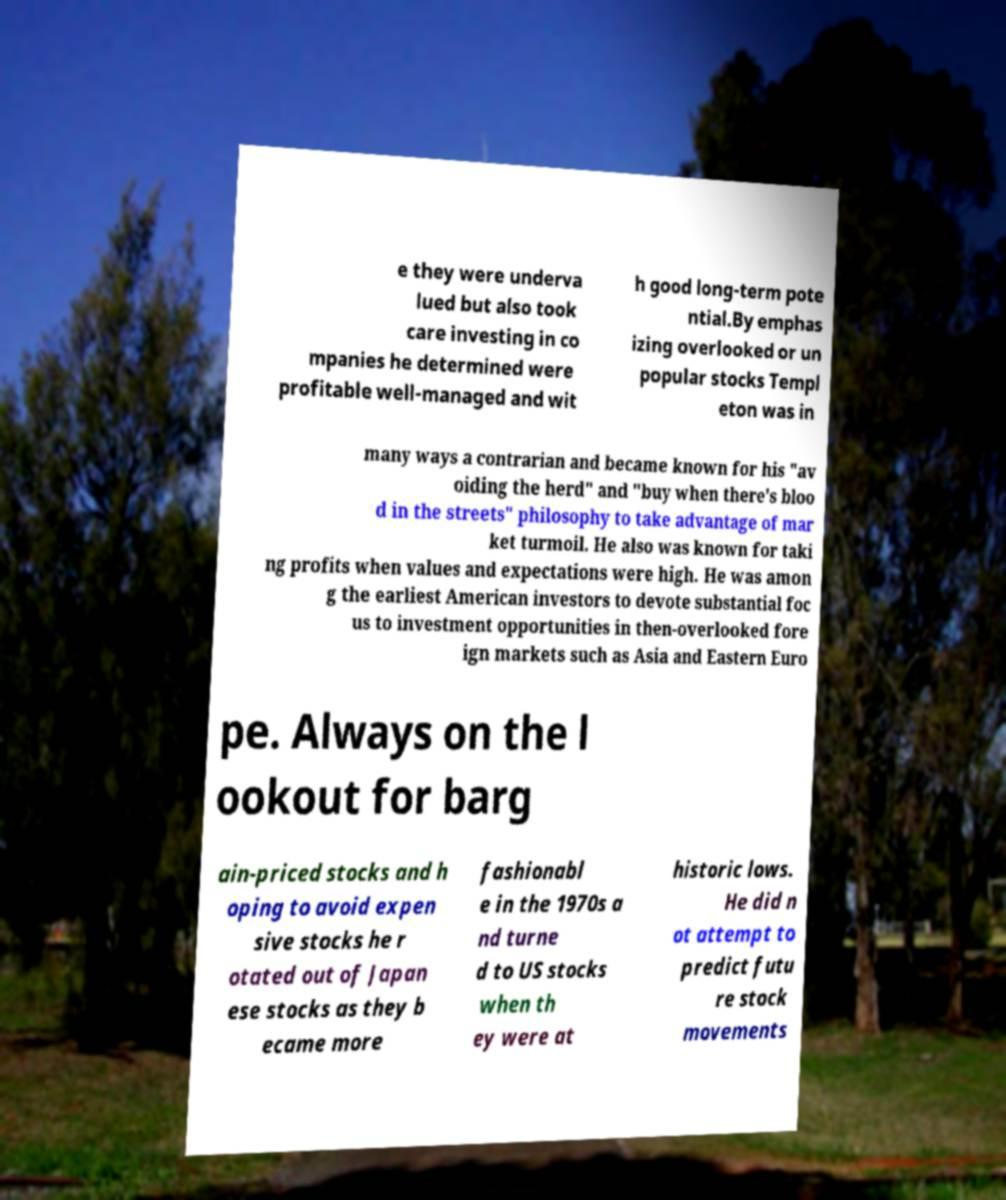There's text embedded in this image that I need extracted. Can you transcribe it verbatim? e they were underva lued but also took care investing in co mpanies he determined were profitable well-managed and wit h good long-term pote ntial.By emphas izing overlooked or un popular stocks Templ eton was in many ways a contrarian and became known for his "av oiding the herd" and "buy when there's bloo d in the streets" philosophy to take advantage of mar ket turmoil. He also was known for taki ng profits when values and expectations were high. He was amon g the earliest American investors to devote substantial foc us to investment opportunities in then-overlooked fore ign markets such as Asia and Eastern Euro pe. Always on the l ookout for barg ain-priced stocks and h oping to avoid expen sive stocks he r otated out of Japan ese stocks as they b ecame more fashionabl e in the 1970s a nd turne d to US stocks when th ey were at historic lows. He did n ot attempt to predict futu re stock movements 